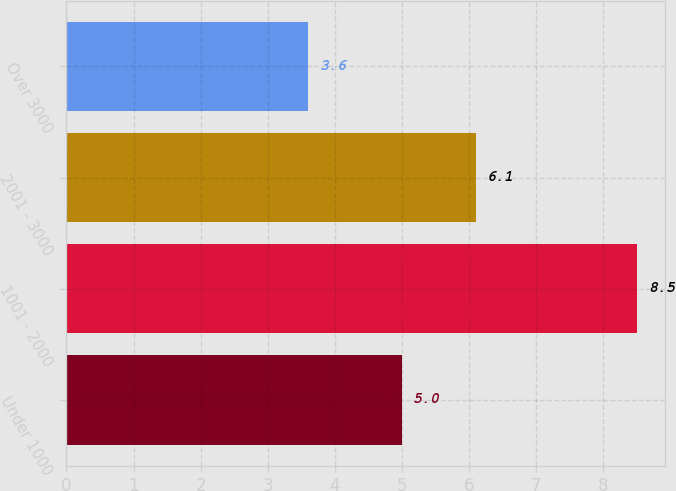Convert chart. <chart><loc_0><loc_0><loc_500><loc_500><bar_chart><fcel>Under 1000<fcel>1001 - 2000<fcel>2001 - 3000<fcel>Over 3000<nl><fcel>5<fcel>8.5<fcel>6.1<fcel>3.6<nl></chart> 